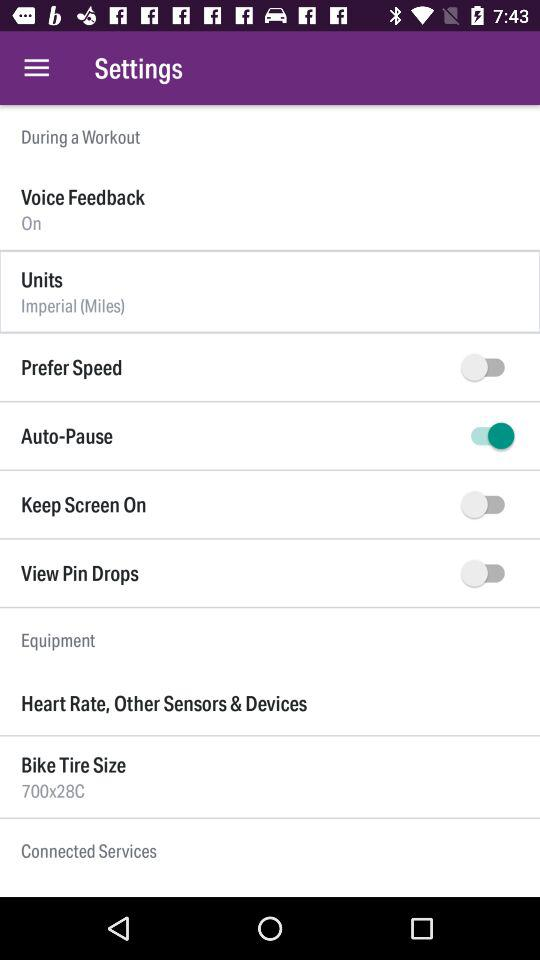What is the size of a Bike Tire? The size is 700×280. 